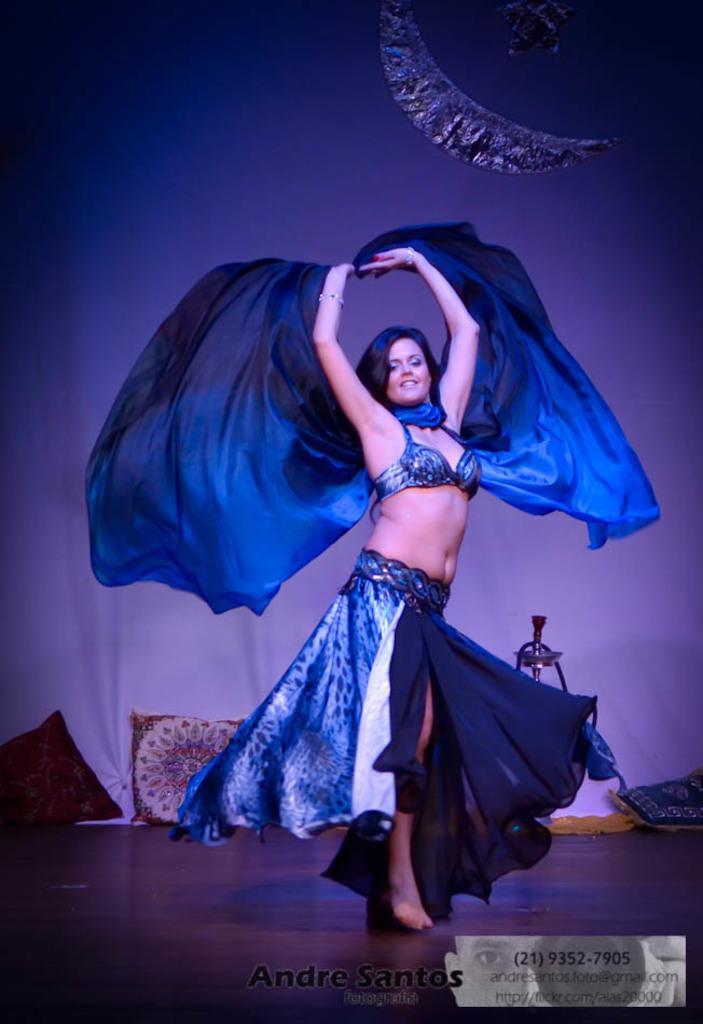Describe this image in one or two sentences. In this image I can see a woman wearing blue color dress, smiling and dancing on the floor. In the background, I can see white color curtain and there are some pillows. At the bottom of the image I can see some edited text. 